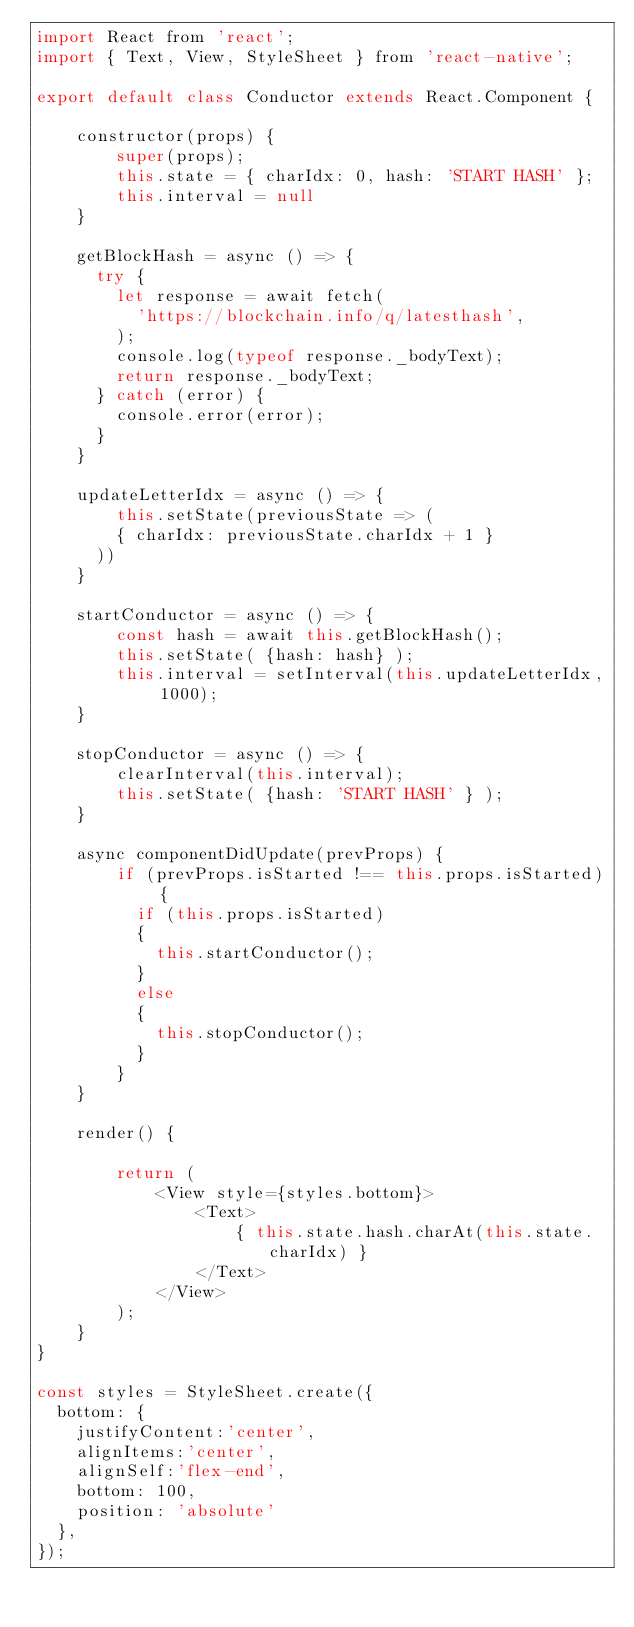<code> <loc_0><loc_0><loc_500><loc_500><_JavaScript_>import React from 'react';
import { Text, View, StyleSheet } from 'react-native';

export default class Conductor extends React.Component {

	constructor(props) {
    	super(props);
    	this.state = { charIdx: 0, hash: 'START HASH' };
    	this.interval = null
  	}

  	getBlockHash = async () => {
	  try {
	    let response = await fetch(
	      'https://blockchain.info/q/latesthash',
	    );
	    console.log(typeof response._bodyText);
	    return response._bodyText;
	  } catch (error) {
	    console.error(error);
	  }
	}

	updateLetterIdx = async () => {
		this.setState(previousState => (
        { charIdx: previousState.charIdx + 1 }
      ))	
	}

	startConductor = async () => {
		const hash = await this.getBlockHash();
		this.setState( {hash: hash} );
    	this.interval = setInterval(this.updateLetterIdx, 1000);
	}

	stopConductor = async () => {
		clearInterval(this.interval);
		this.setState( {hash: 'START HASH' } );
	}

	async componentDidUpdate(prevProps) {
	    if (prevProps.isStarted !== this.props.isStarted) {
	      if (this.props.isStarted) 
	      {
	        this.startConductor();
	      }
	      else 
	      {
	        this.stopConductor();
	      }
	    }
	}

	render() {

		return (
			<View style={styles.bottom}>
	        	<Text>
	        		{ this.state.hash.charAt(this.state.charIdx) }
	        	</Text>
	      	</View>
	    );
	}
}

const styles = StyleSheet.create({
  bottom: {
    justifyContent:'center',
    alignItems:'center',
    alignSelf:'flex-end',
    bottom: 100,
    position: 'absolute'
  },
});</code> 